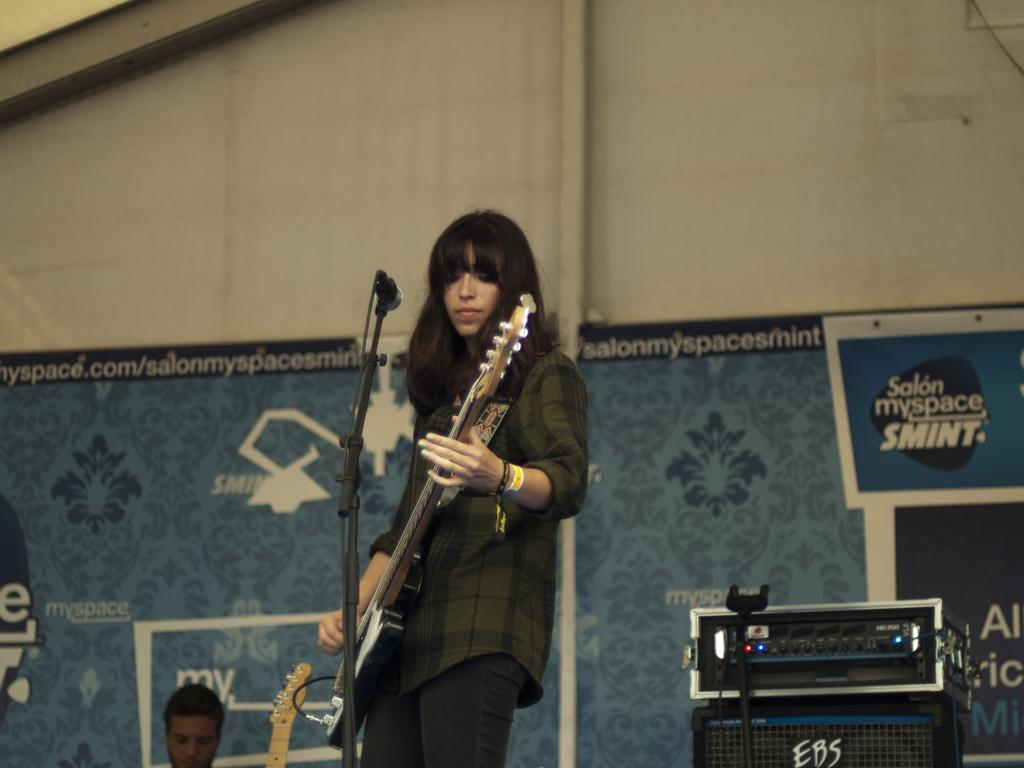Who is the main subject in the image? There is a woman in the image. What is the woman doing in the image? The woman is playing a guitar. What object is in front of the woman? There is a microphone in front of the woman. How many trains can be seen in the image? There are no trains present in the image. What type of lace is draped over the microphone in the image? There is no lace present in the image; only a microphone and a woman playing a guitar are visible. 